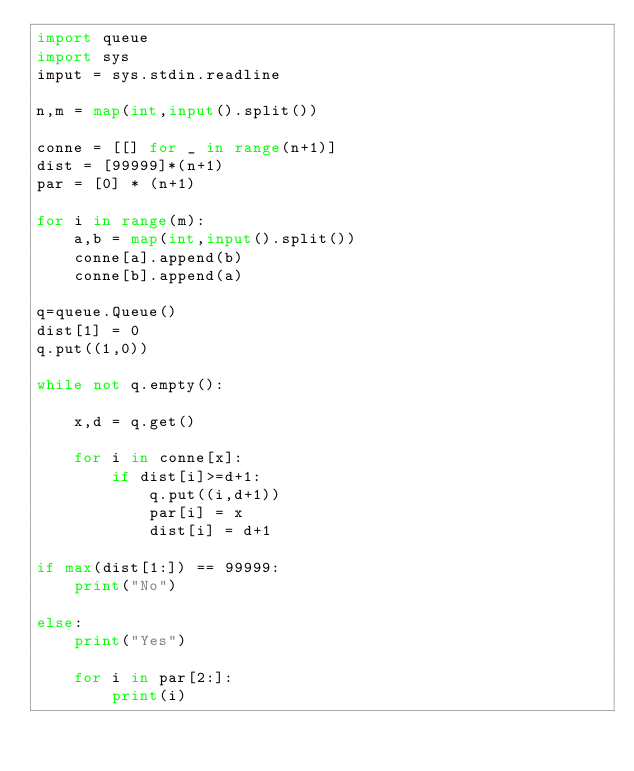Convert code to text. <code><loc_0><loc_0><loc_500><loc_500><_Python_>import queue
import sys
imput = sys.stdin.readline

n,m = map(int,input().split()) 

conne = [[] for _ in range(n+1)]
dist = [99999]*(n+1)
par = [0] * (n+1)

for i in range(m):
    a,b = map(int,input().split()) 
    conne[a].append(b)
    conne[b].append(a)
    
q=queue.Queue()
dist[1] = 0
q.put((1,0))

while not q.empty():
    
    x,d = q.get()
    
    for i in conne[x]:
        if dist[i]>=d+1:
            q.put((i,d+1))
            par[i] = x
            dist[i] = d+1

if max(dist[1:]) == 99999:
    print("No")
    
else:
    print("Yes")    
    
    for i in par[2:]:
        print(i)
    
</code> 